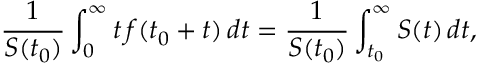<formula> <loc_0><loc_0><loc_500><loc_500>{ \frac { 1 } { S ( t _ { 0 } ) } } \int _ { 0 } ^ { \infty } t \, f ( t _ { 0 } + t ) \, d t = { \frac { 1 } { S ( t _ { 0 } ) } } \int _ { t _ { 0 } } ^ { \infty } S ( t ) \, d t ,</formula> 